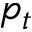Convert formula to latex. <formula><loc_0><loc_0><loc_500><loc_500>p _ { t }</formula> 